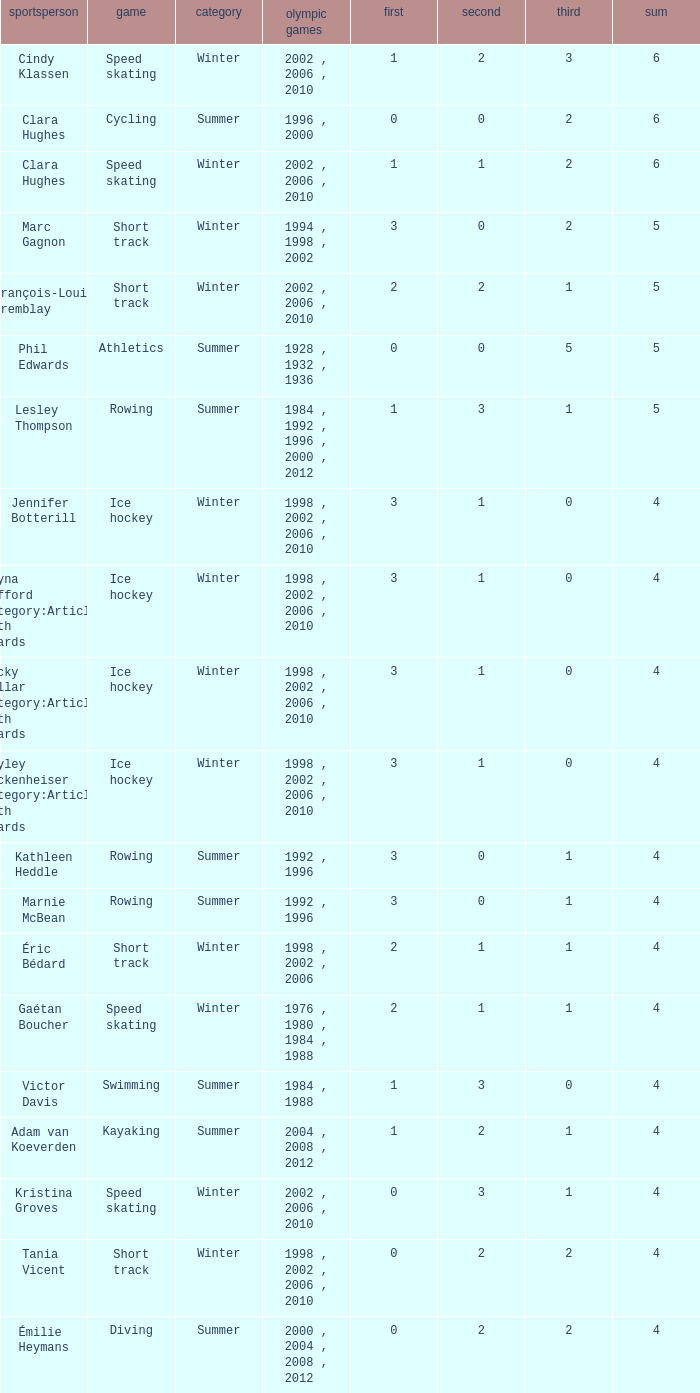What is the highest total medals winter athlete Clara Hughes has? 6.0. 